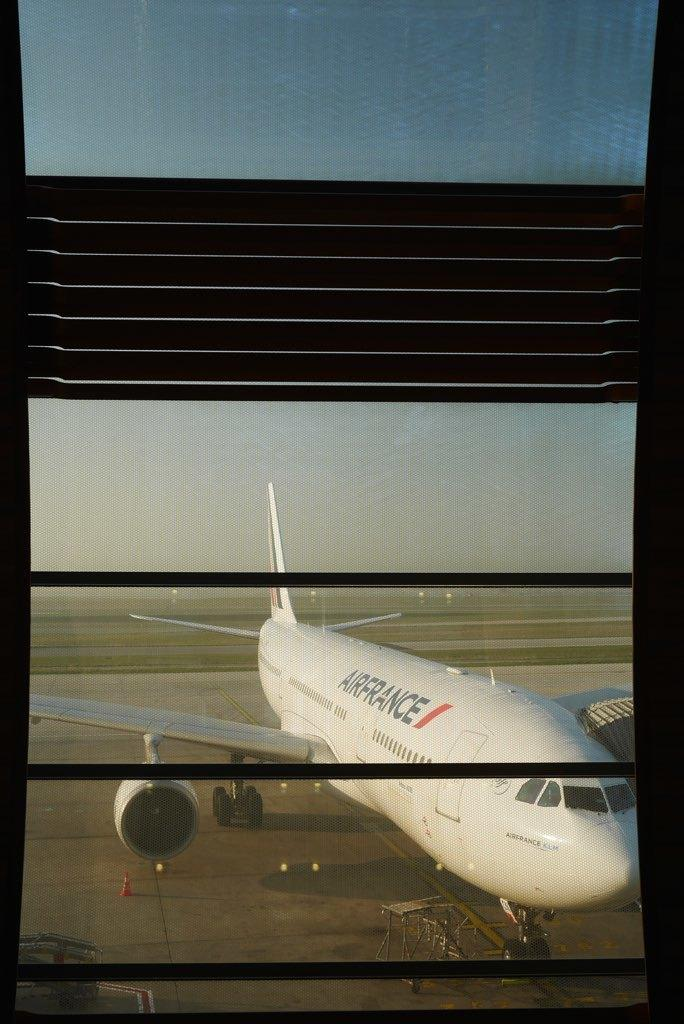Provide a one-sentence caption for the provided image. A large Airfrance plane sits on the runway. 